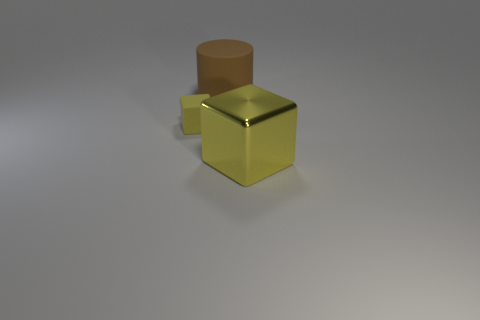There is a large thing that is behind the block on the right side of the tiny rubber thing; what shape is it?
Your response must be concise. Cylinder. How many objects are yellow objects or large things that are in front of the large brown thing?
Offer a very short reply. 2. What is the color of the matte thing that is behind the cube to the left of the yellow thing that is right of the large brown object?
Offer a terse response. Brown. There is another thing that is the same shape as the yellow metallic thing; what is it made of?
Ensure brevity in your answer.  Rubber. What color is the cylinder?
Your answer should be compact. Brown. Do the small rubber thing and the metallic block have the same color?
Ensure brevity in your answer.  Yes. What number of matte objects are yellow objects or large brown things?
Your answer should be compact. 2. There is a yellow cube that is behind the yellow thing in front of the tiny rubber block; are there any rubber cubes in front of it?
Offer a very short reply. No. The brown thing that is made of the same material as the small block is what size?
Offer a terse response. Large. There is a small rubber block; are there any yellow cubes on the right side of it?
Keep it short and to the point. Yes. 